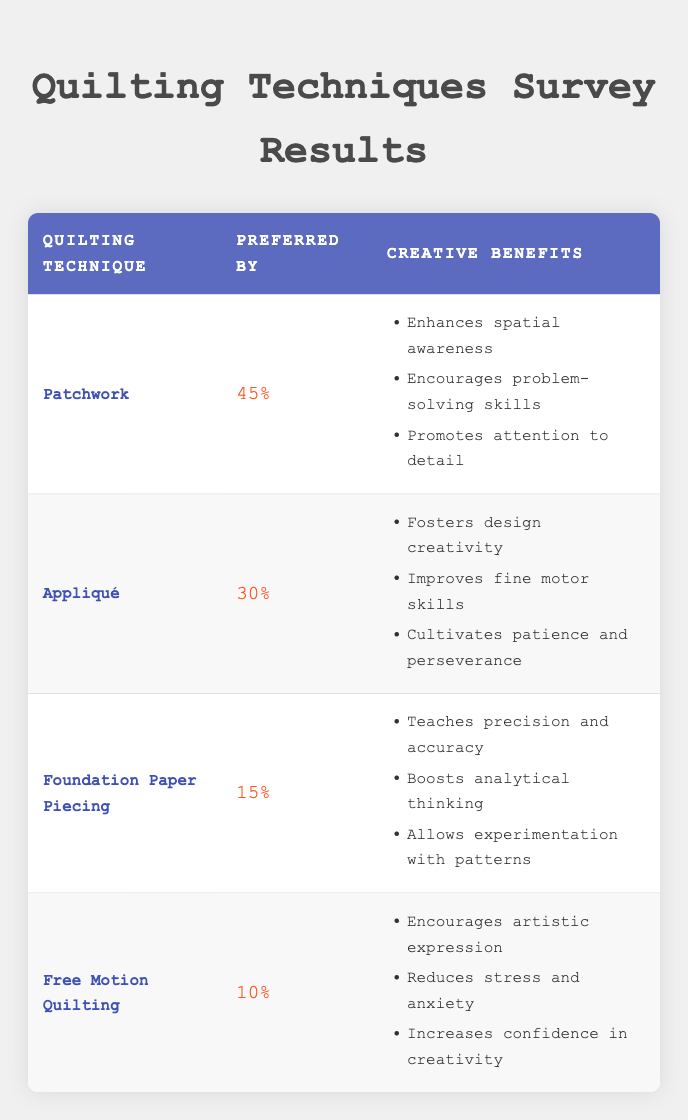What percentage of respondents prefer Patchwork as a quilting technique? According to the table, Patchwork is preferred by 45% of the respondents.
Answer: 45% Which quilting technique has the least preference among the surveyed software engineers? The table shows that Free Motion Quilting has the least preference, with only 10% of respondents opting for this technique.
Answer: Free Motion Quilting What are the creative benefits of using Appliqué? The table lists three creative benefits of Appliqué, which are fostering design creativity, improving fine motor skills, and cultivating patience and perseverance.
Answer: Fostering design creativity, improving fine motor skills, cultivating patience and perseverance What is the combined percentage of respondents who prefer Foundation Paper Piecing and Free Motion Quilting? To find the combined percentage, add the percentages for Foundation Paper Piecing (15%) and Free Motion Quilting (10%): 15 + 10 = 25.
Answer: 25% Is it true that more than half of the surveyed software engineers prefer Patchwork? Since Patchwork is preferred by 45% of the respondents, which is less than half (50%), the statement is false.
Answer: No Which quilting technique promotes both attention to detail and analytical thinking? The table indicates that Patchwork promotes attention to detail and Foundation Paper Piecing boosts analytical thinking, but no single technique incorporates both benefits directly. Therefore, the answer implies considering two different techniques.
Answer: None (separate techniques) What are the creative benefits associated with Free Motion Quilting? The table outlines that Free Motion Quilting encourages artistic expression, reduces stress and anxiety, and increases confidence in creativity as its creative benefits.
Answer: Encourages artistic expression, reduces stress and anxiety, increases confidence in creativity What is the average percentage of preference for the four quilting techniques listed? To calculate the average, add the preferred percentages (Patchwork 45% + Appliqué 30% + Foundation Paper Piecing 15% + Free Motion Quilting 10%) to get 100%. Then divide by the number of techniques (4): 100/4 = 25%.
Answer: 25% 